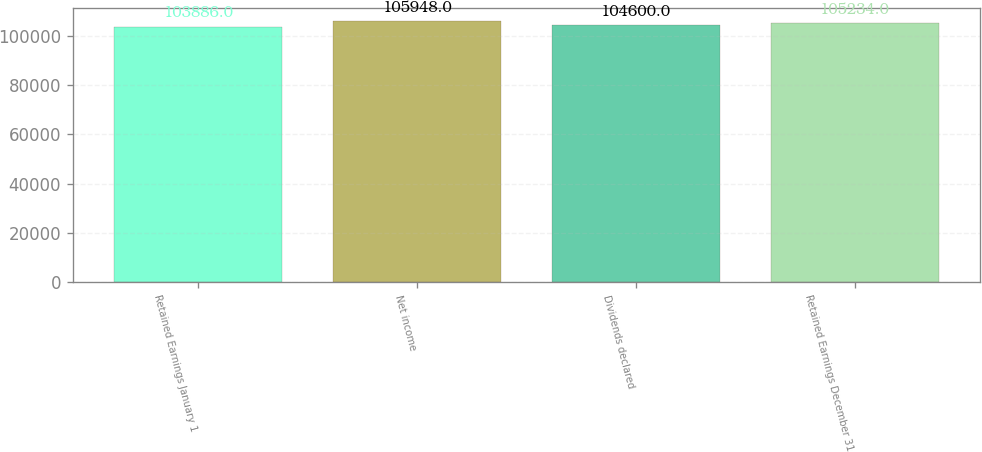<chart> <loc_0><loc_0><loc_500><loc_500><bar_chart><fcel>Retained Earnings January 1<fcel>Net income<fcel>Dividends declared<fcel>Retained Earnings December 31<nl><fcel>103886<fcel>105948<fcel>104600<fcel>105234<nl></chart> 